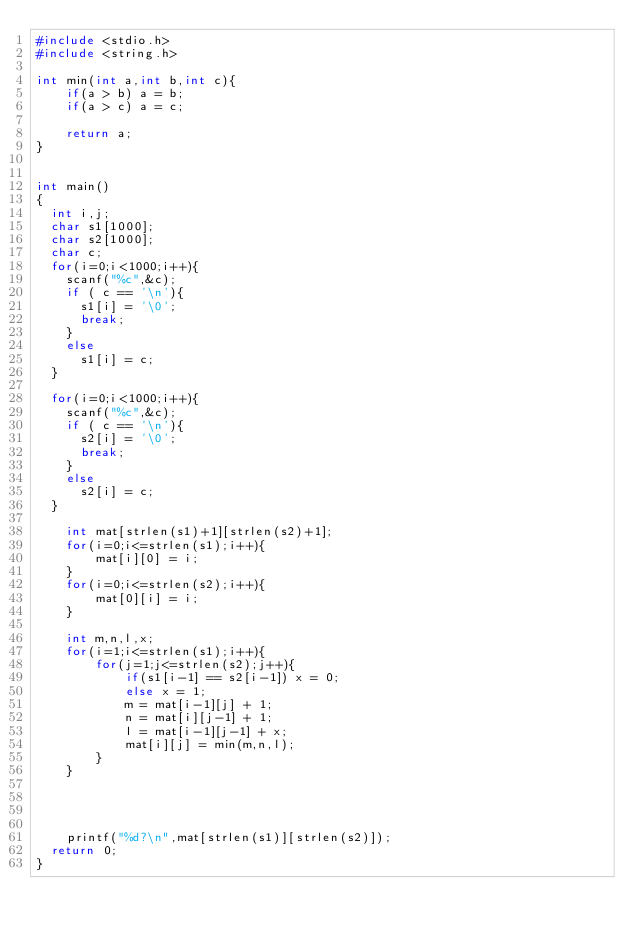Convert code to text. <code><loc_0><loc_0><loc_500><loc_500><_C_>#include <stdio.h>
#include <string.h>

int min(int a,int b,int c){
    if(a > b) a = b;
    if(a > c) a = c;
    
    return a;
}
  

int main()
{
  int i,j;
  char s1[1000];
  char s2[1000];
  char c;
  for(i=0;i<1000;i++){
    scanf("%c",&c);
    if ( c == '\n'){
      s1[i] = '\0';
      break;
    }
    else
      s1[i] = c;
  }
  
  for(i=0;i<1000;i++){
    scanf("%c",&c);
    if ( c == '\n'){
      s2[i] = '\0';
      break;
    }
    else
      s2[i] = c;
  }
    
    int mat[strlen(s1)+1][strlen(s2)+1];
    for(i=0;i<=strlen(s1);i++){
        mat[i][0] = i;
    }
    for(i=0;i<=strlen(s2);i++){
        mat[0][i] = i;
    }
    
    int m,n,l,x;
    for(i=1;i<=strlen(s1);i++){
        for(j=1;j<=strlen(s2);j++){
            if(s1[i-1] == s2[i-1]) x = 0;
            else x = 1;
            m = mat[i-1][j] + 1;
            n = mat[i][j-1] + 1;
            l = mat[i-1][j-1] + x;
            mat[i][j] = min(m,n,l);
        }
    }
    
    
	

    printf("%d?\n",mat[strlen(s1)][strlen(s2)]);
  return 0;
}
    </code> 